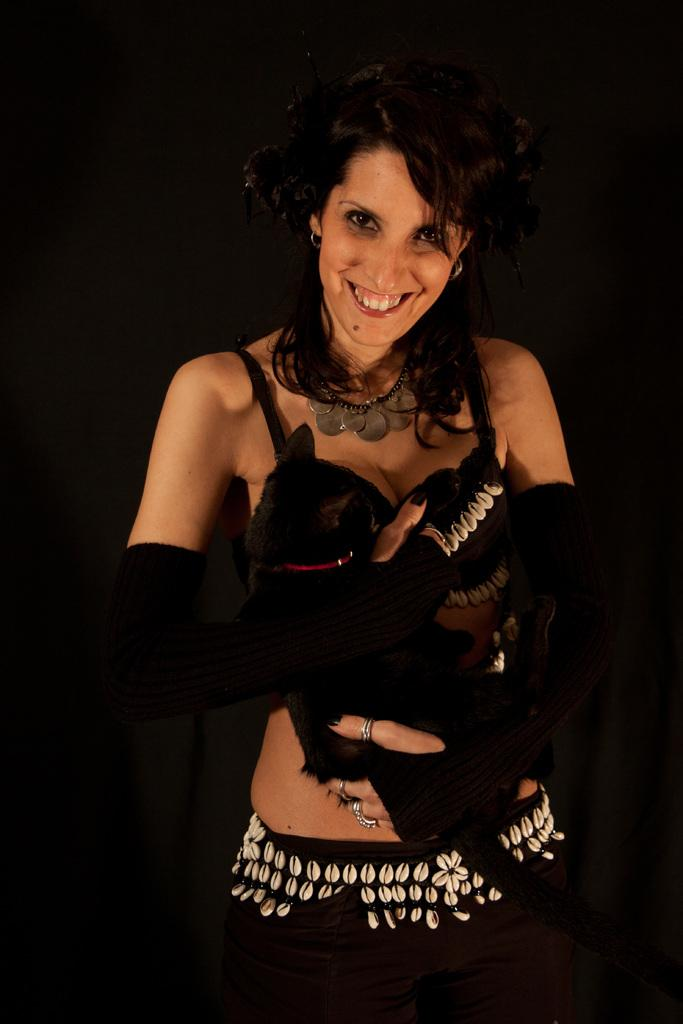Who is the main subject in the image? There is a woman in the image. What is the woman doing in the image? The woman is standing in the image. What expression does the woman have? The woman is smiling in the image. What color is the woman's top? The woman is wearing a black top. What accessory is the woman wearing on her hands? The woman is wearing black gloves. What can be observed about the background of the image? The background of the image appears to be dark. What type of plane can be seen in the woman's hand in the image? There is no plane visible in the woman's hand or anywhere else in the image. How many sticks are the woman holding in the image? There are no sticks present in the image. 